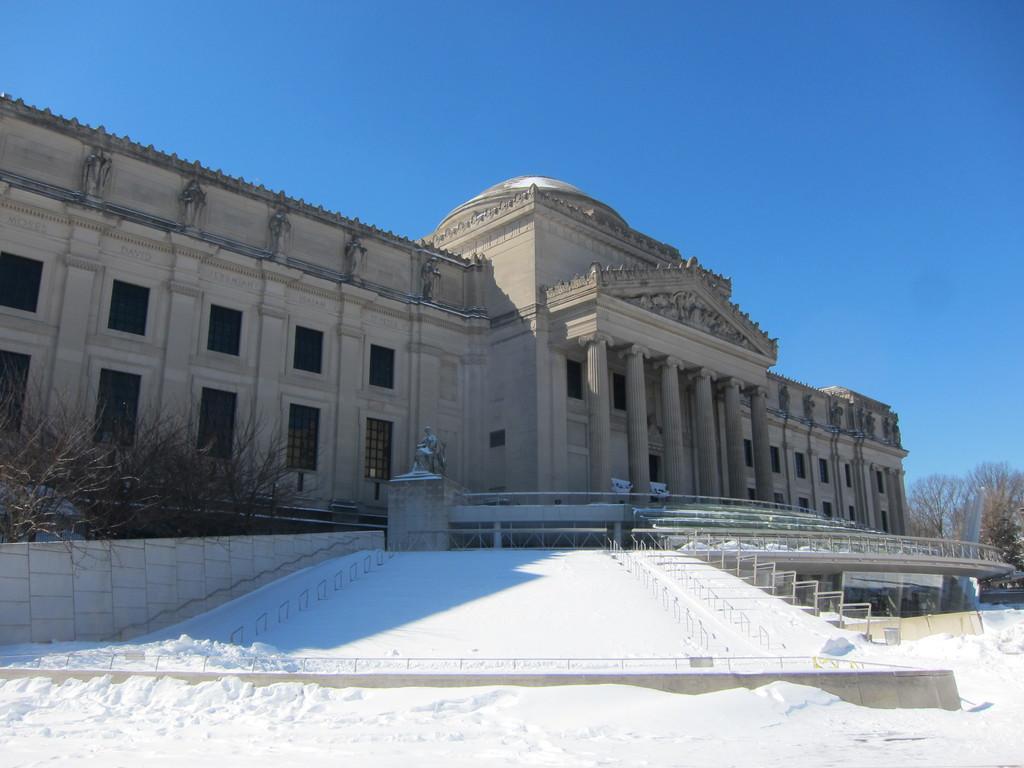How would you summarize this image in a sentence or two? In this image I can see few plants. In the background I can see the building in cream color and the sky is in blue color. 